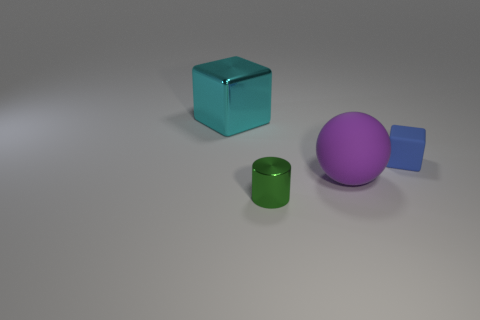How many metallic objects are there?
Keep it short and to the point. 2. Is there anything else that is the same size as the cyan shiny cube?
Your response must be concise. Yes. Do the purple object and the blue thing have the same material?
Keep it short and to the point. Yes. Does the cube to the left of the green thing have the same size as the matte object that is in front of the tiny rubber block?
Keep it short and to the point. Yes. Are there fewer large cyan objects than small things?
Keep it short and to the point. Yes. How many shiny objects are either blue things or big cyan blocks?
Provide a short and direct response. 1. There is a tiny object that is to the left of the purple ball; are there any things on the right side of it?
Offer a terse response. Yes. Is the thing behind the matte cube made of the same material as the tiny cylinder?
Give a very brief answer. Yes. How many other objects are there of the same color as the cylinder?
Your response must be concise. 0. Is the tiny rubber object the same color as the large matte ball?
Your response must be concise. No. 